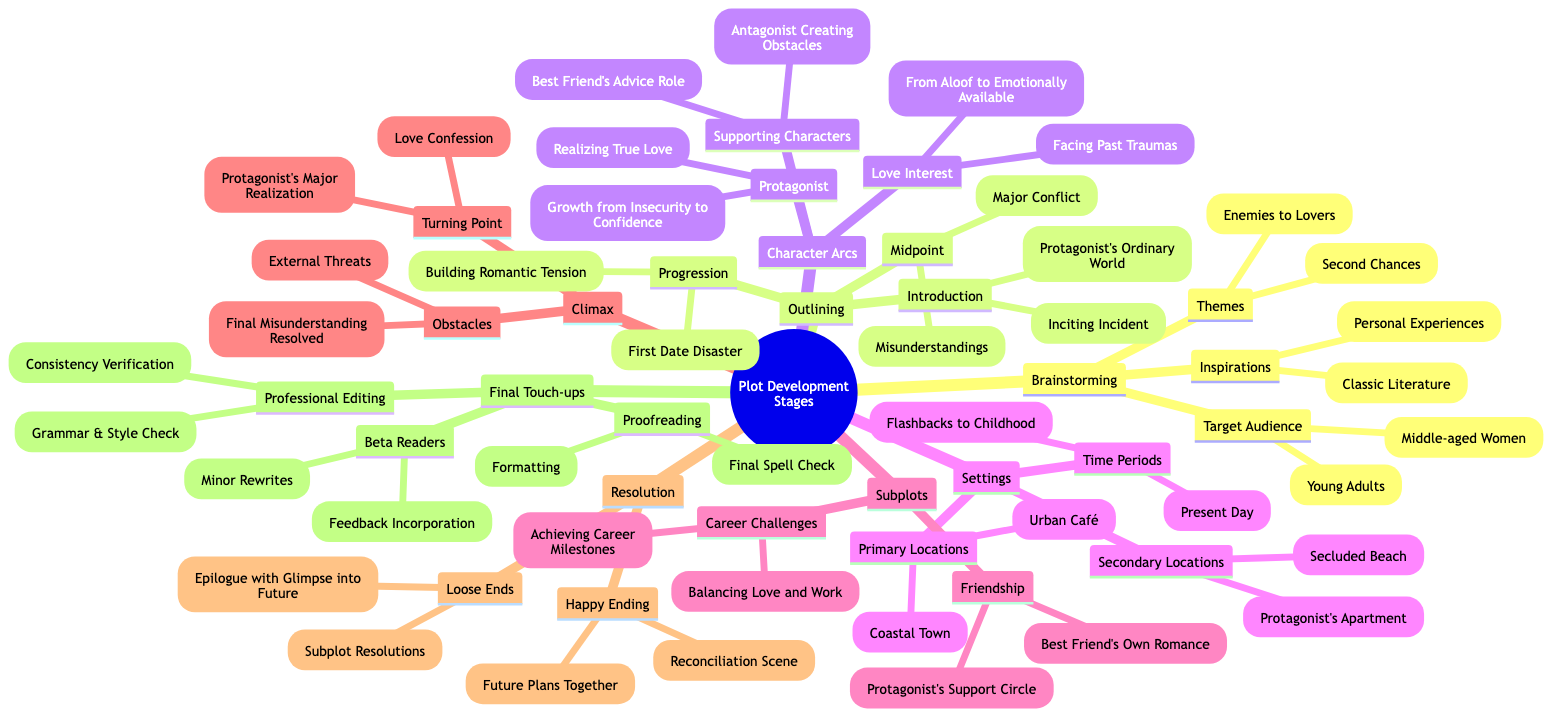What are the themes listed under Brainstorming? Under the "Brainstorming Initial Ideas" node, the themes provided are specifically mentioned. They include "Second Chances" and "Enemies to Lovers."
Answer: Second Chances, Enemies to Lovers How many major plot points are outlined in the diagram? The section "Outlining Major Plot Points" contains three subsections: Introduction, Progression, and Midpoint. Each of these subsections contains specific points, leading to a total of six major plot points when considered collectively.
Answer: 6 What is the main setting's primary location? The "Settings" section indicates that the primary locations include "Coastal Town" and "Urban Café." The first of these is typically considered the main setting.
Answer: Coastal Town What character arc does the protagonist undergo? The "Character Arcs" section under the protagonist clearly states two arcs: "Growth from Insecurity to Confidence" and "Realizing True Love." The first one describes the main transformation of the protagonist.
Answer: Growth from Insecurity to Confidence What are the two elements listed in the Resolution section? In the "Resolution" part of the diagram, there are specific elements provided, which are "Happy Ending" and "Loose Ends." These summarize how the story concludes and how remaining plot threads are handled.
Answer: Happy Ending, Loose Ends What is the main focus of the Subplots section? The "Subplots" section features two prominent focuses: "Friendship" and "Career Challenges." These facets delve deeper into the supporting narratives that enrich the primary romantic plot.
Answer: Friendship, Career Challenges What is involved in the Final Touch-ups before publishing? The "Final Touch-ups" node is detailed with professional editing, beta readers, and proofreading as key components. Professional editing includes checking for grammar and consistency, which is crucial for the final draft.
Answer: Professional Editing, Beta Readers, Proofreading Which subplot involves love and work balance? In the "Subplots" section, one of the points listed under "Career Challenges" is "Balancing Love and Work," representing the intersection of romantic and professional narratives in the story arc.
Answer: Balancing Love and Work What is considered the Climax of the story? Under the "Climax" section, key happenings denote major turning points, including "Protagonist's Major Realization" and "Love Confession," both critical for the narrative peak leading to the resolution.
Answer: Protagonist's Major Realization, Love Confession 